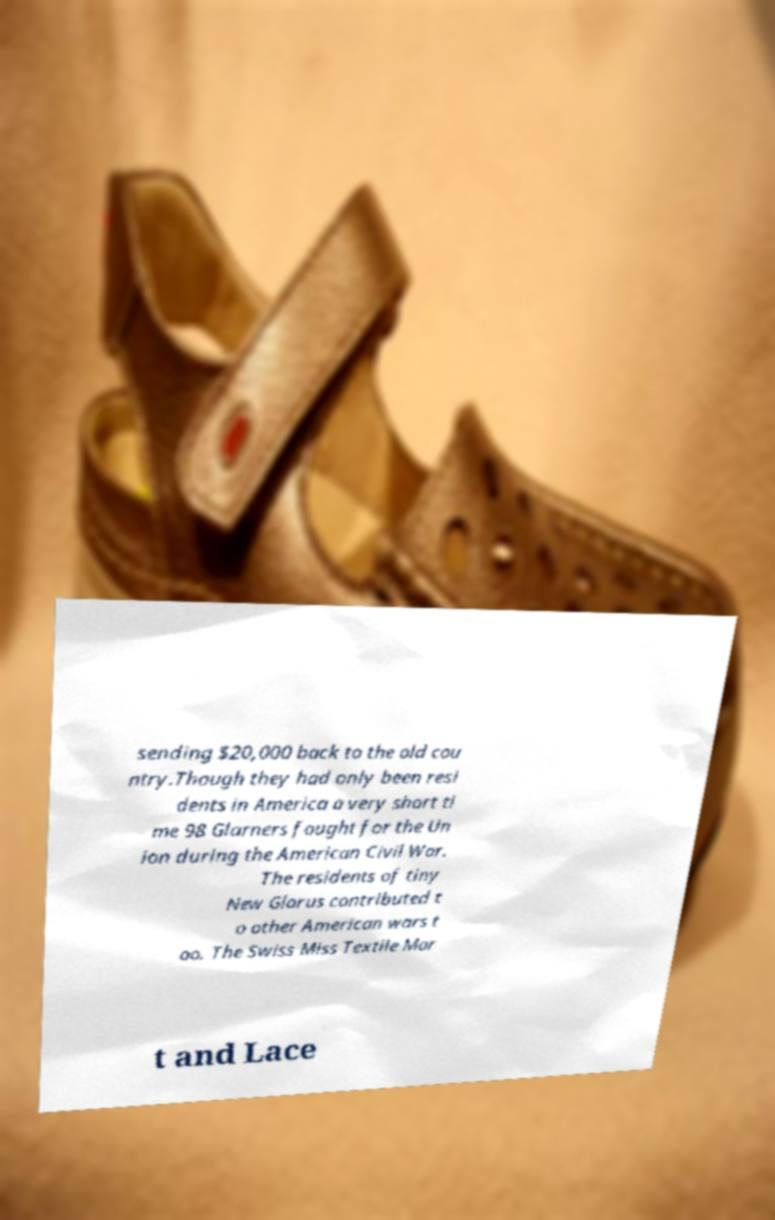Can you read and provide the text displayed in the image?This photo seems to have some interesting text. Can you extract and type it out for me? sending $20,000 back to the old cou ntry.Though they had only been resi dents in America a very short ti me 98 Glarners fought for the Un ion during the American Civil War. The residents of tiny New Glarus contributed t o other American wars t oo. The Swiss Miss Textile Mar t and Lace 